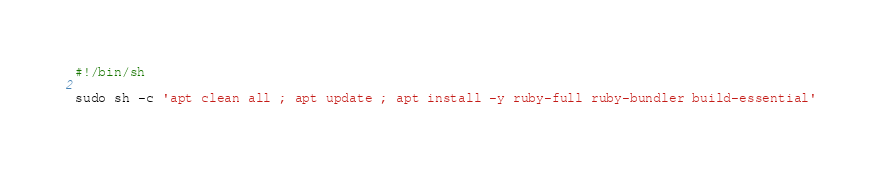<code> <loc_0><loc_0><loc_500><loc_500><_Bash_>#!/bin/sh

sudo sh -c 'apt clean all ; apt update ; apt install -y ruby-full ruby-bundler build-essential'
</code> 